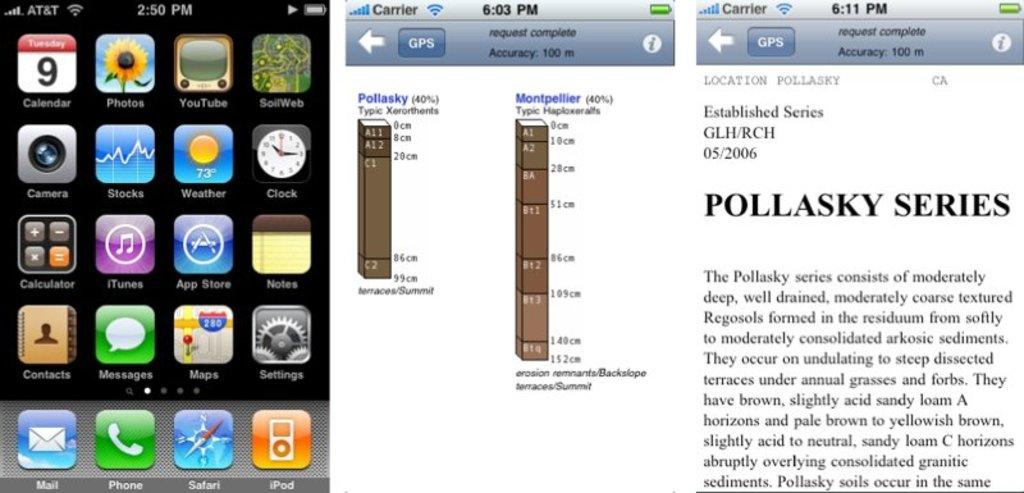<image>
Share a concise interpretation of the image provided. several screen shots from a cellphone for the Pollasky Series 